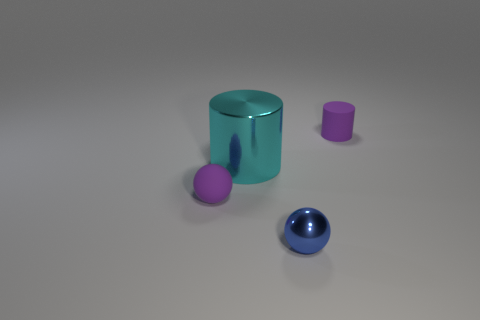Subtract 1 cylinders. How many cylinders are left? 1 Subtract all green blocks. How many blue cylinders are left? 0 Add 4 shiny spheres. How many shiny spheres exist? 5 Add 2 yellow rubber cylinders. How many objects exist? 6 Subtract 1 purple cylinders. How many objects are left? 3 Subtract all gray spheres. Subtract all brown cubes. How many spheres are left? 2 Subtract all tiny blue things. Subtract all shiny spheres. How many objects are left? 2 Add 1 blue things. How many blue things are left? 2 